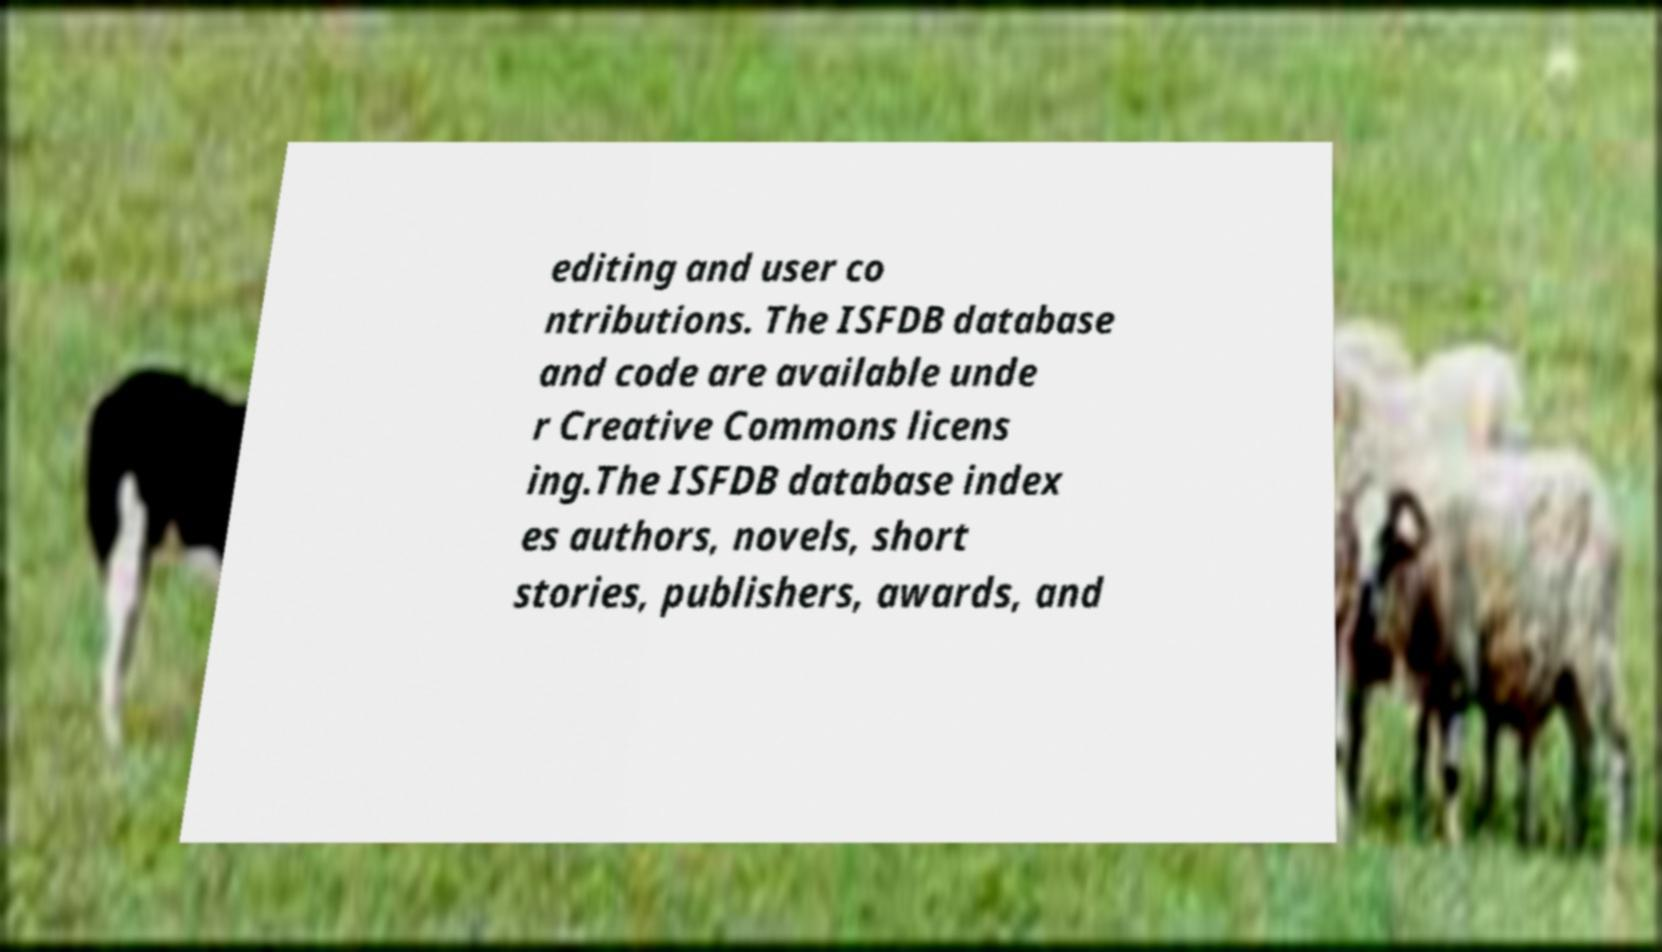Could you extract and type out the text from this image? editing and user co ntributions. The ISFDB database and code are available unde r Creative Commons licens ing.The ISFDB database index es authors, novels, short stories, publishers, awards, and 